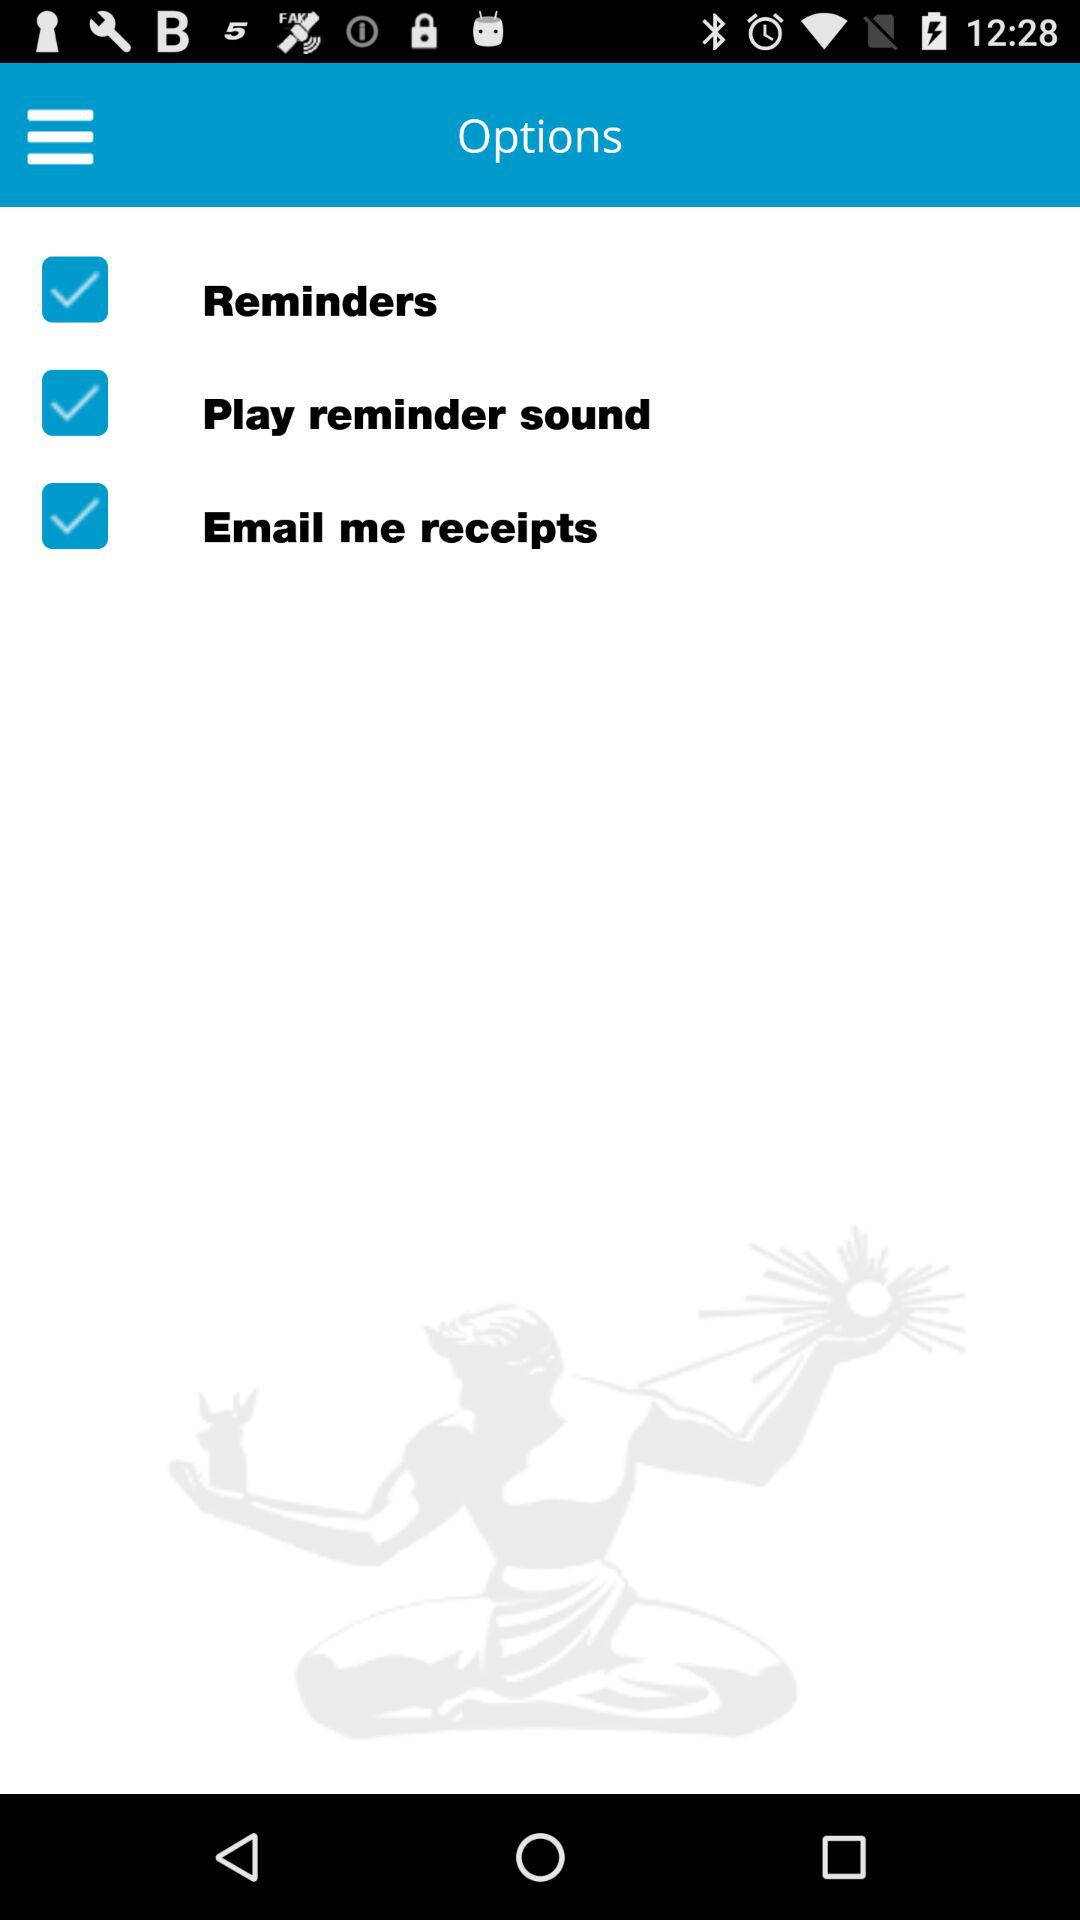When will the application email me a receipt?
When the provided information is insufficient, respond with <no answer>. <no answer> 